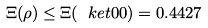Convert formula to latex. <formula><loc_0><loc_0><loc_500><loc_500>\Xi ( \rho ) \leq \Xi ( \ k e t { 0 0 } ) = 0 . 4 4 2 7</formula> 